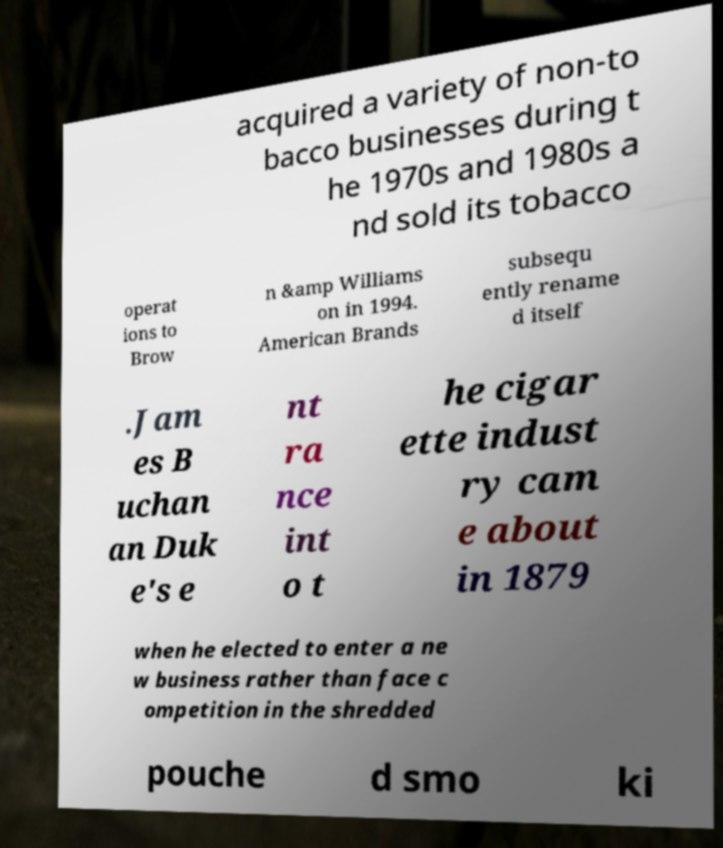Can you read and provide the text displayed in the image?This photo seems to have some interesting text. Can you extract and type it out for me? acquired a variety of non-to bacco businesses during t he 1970s and 1980s a nd sold its tobacco operat ions to Brow n &amp Williams on in 1994. American Brands subsequ ently rename d itself .Jam es B uchan an Duk e's e nt ra nce int o t he cigar ette indust ry cam e about in 1879 when he elected to enter a ne w business rather than face c ompetition in the shredded pouche d smo ki 